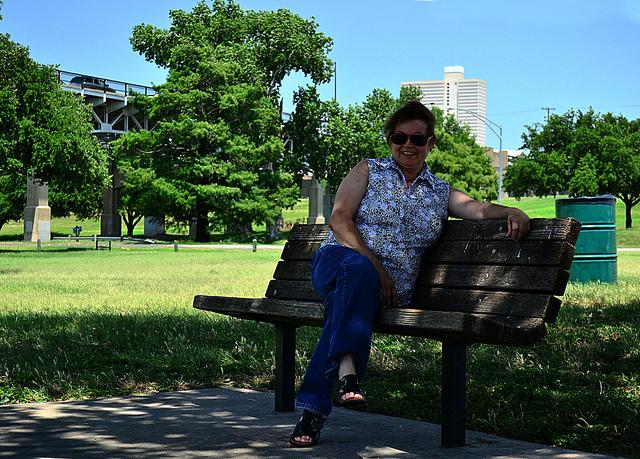What outdoor area is the woman sitting in? park 